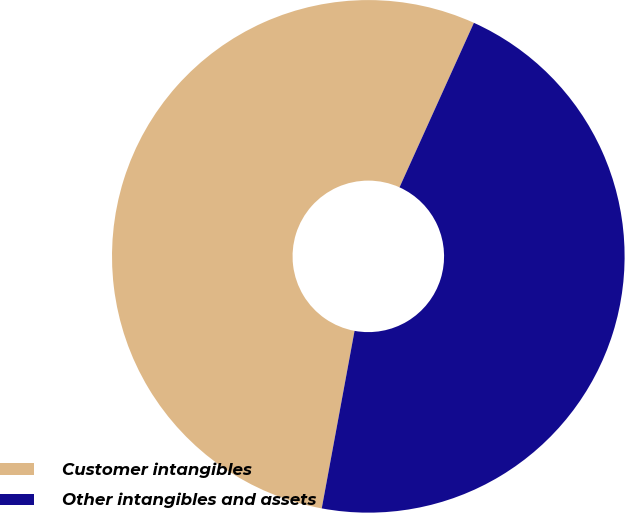<chart> <loc_0><loc_0><loc_500><loc_500><pie_chart><fcel>Customer intangibles<fcel>Other intangibles and assets<nl><fcel>53.85%<fcel>46.15%<nl></chart> 